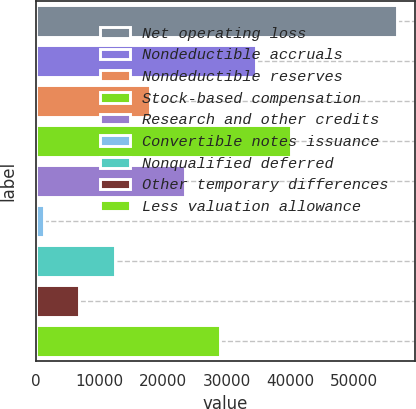<chart> <loc_0><loc_0><loc_500><loc_500><bar_chart><fcel>Net operating loss<fcel>Nondeductible accruals<fcel>Nondeductible reserves<fcel>Stock-based compensation<fcel>Research and other credits<fcel>Convertible notes issuance<fcel>Nonqualified deferred<fcel>Other temporary differences<fcel>Less valuation allowance<nl><fcel>56641<fcel>34497.8<fcel>17890.4<fcel>40033.6<fcel>23426.2<fcel>1283<fcel>12354.6<fcel>6818.8<fcel>28962<nl></chart> 